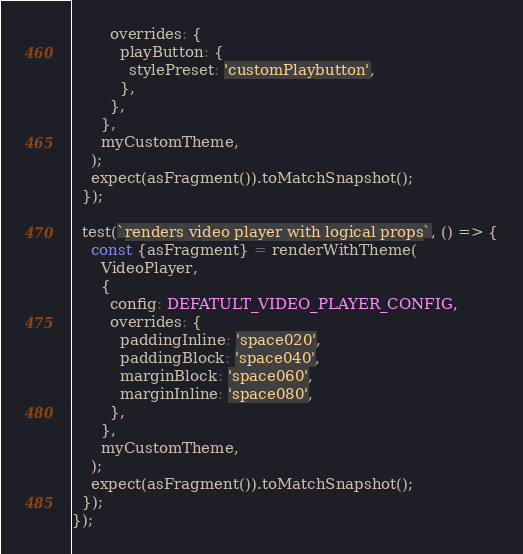<code> <loc_0><loc_0><loc_500><loc_500><_TypeScript_>        overrides: {
          playButton: {
            stylePreset: 'customPlaybutton',
          },
        },
      },
      myCustomTheme,
    );
    expect(asFragment()).toMatchSnapshot();
  });

  test(`renders video player with logical props`, () => {
    const {asFragment} = renderWithTheme(
      VideoPlayer,
      {
        config: DEFATULT_VIDEO_PLAYER_CONFIG,
        overrides: {
          paddingInline: 'space020',
          paddingBlock: 'space040',
          marginBlock: 'space060',
          marginInline: 'space080',
        },
      },
      myCustomTheme,
    );
    expect(asFragment()).toMatchSnapshot();
  });
});
</code> 